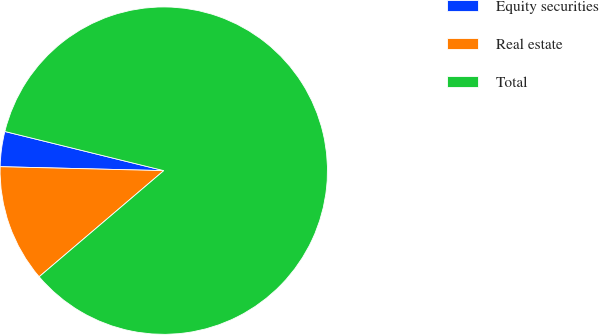<chart> <loc_0><loc_0><loc_500><loc_500><pie_chart><fcel>Equity securities<fcel>Real estate<fcel>Total<nl><fcel>3.46%<fcel>11.61%<fcel>84.93%<nl></chart> 